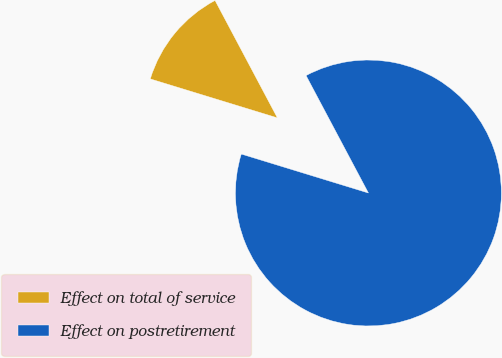<chart> <loc_0><loc_0><loc_500><loc_500><pie_chart><fcel>Effect on total of service<fcel>Effect on postretirement<nl><fcel>12.5%<fcel>87.5%<nl></chart> 